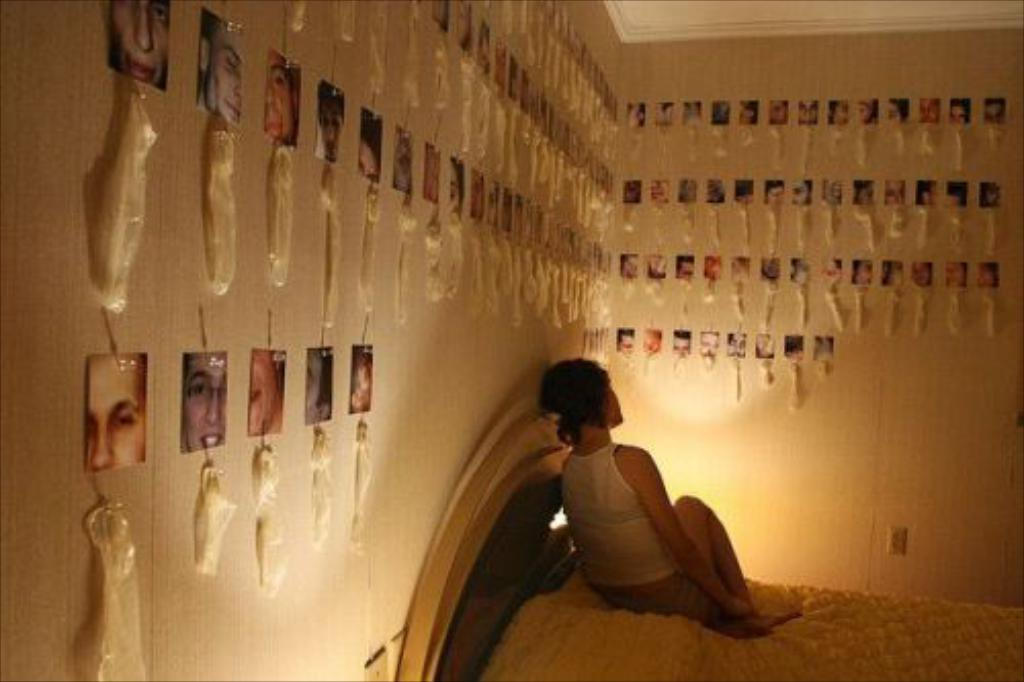What is the woman doing in the image? The woman is seated on the bed in the image. What can be seen on the wall in the image? There are photos on the wall in the image. Can you tell me how the woman is preparing to give birth in the image? There is no indication in the image that the woman is preparing to give birth. 